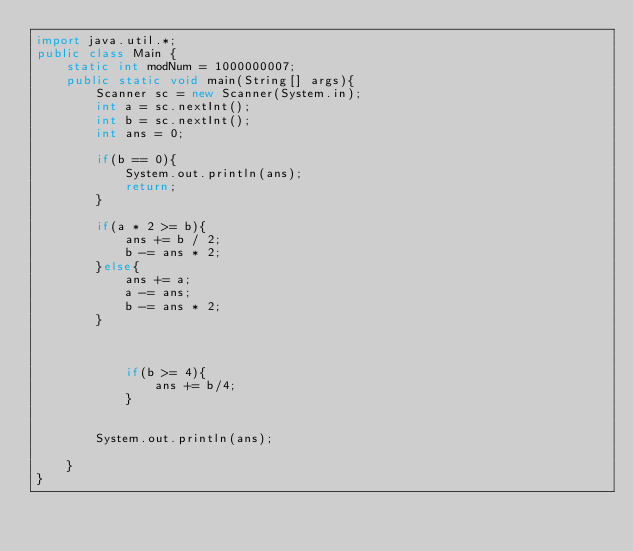Convert code to text. <code><loc_0><loc_0><loc_500><loc_500><_Java_>import java.util.*;
public class Main {
	static int modNum = 1000000007;
	public static void main(String[] args){
		Scanner sc = new Scanner(System.in);
		int a = sc.nextInt();
		int b = sc.nextInt();
		int ans = 0;
	
		if(b == 0){
			System.out.println(ans);
			return;
		}
		
		if(a * 2 >= b){
			ans += b / 2;
			b -= ans * 2;
		}else{
			ans += a;
			a -= ans;
			b -= ans * 2;			
		}
		
		
		
			if(b >= 4){
				ans += b/4;
			}
		
		
		System.out.println(ans);
		
	}
}</code> 